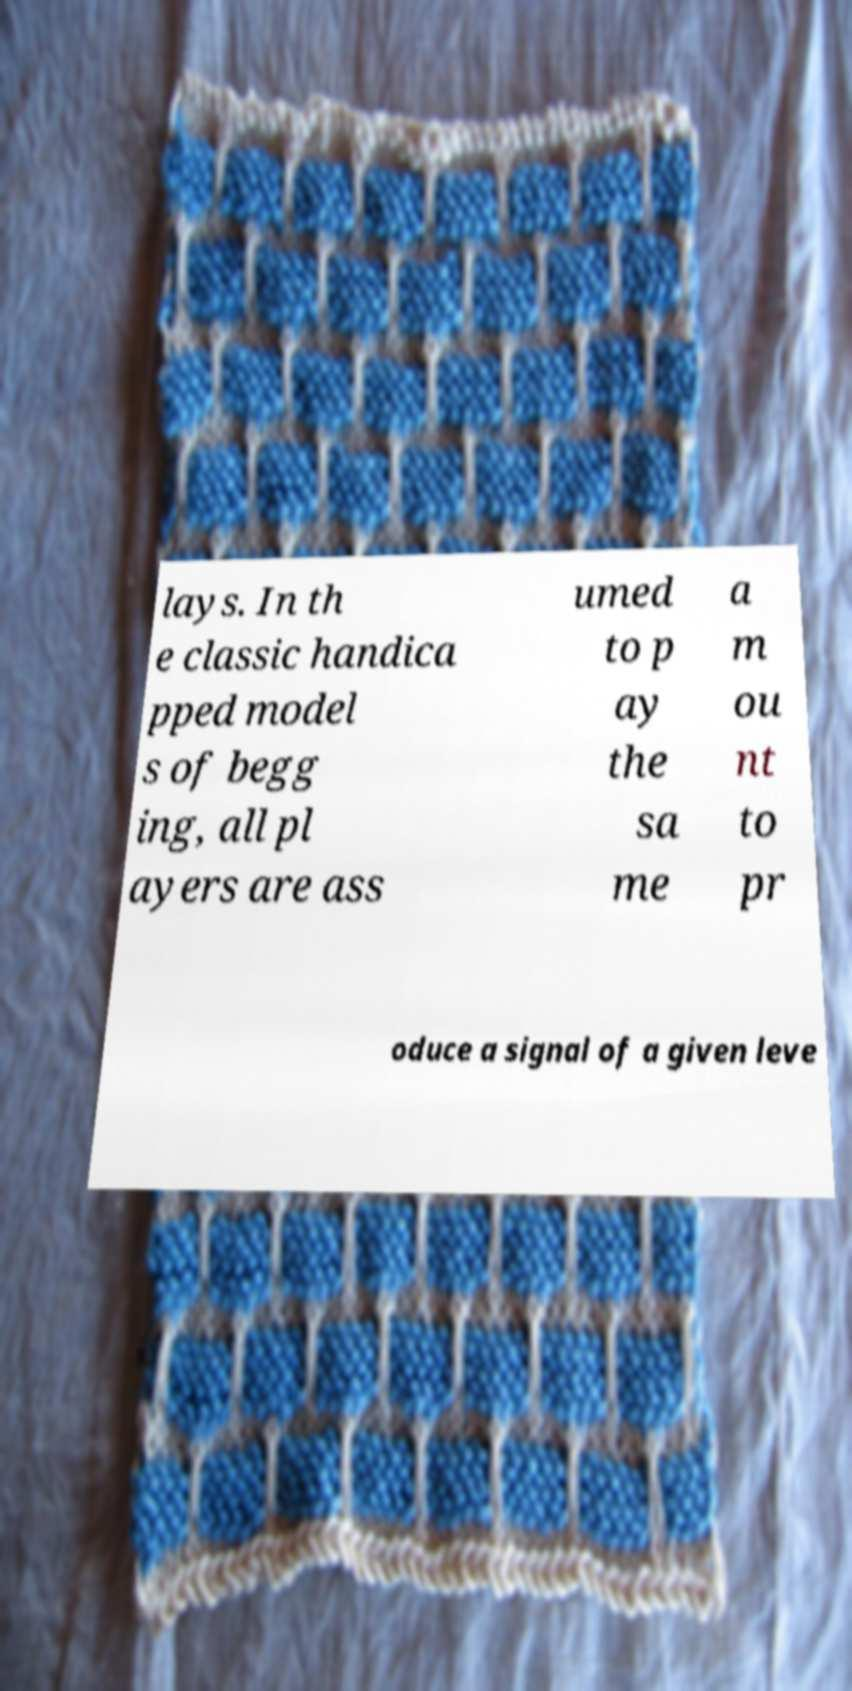What messages or text are displayed in this image? I need them in a readable, typed format. lays. In th e classic handica pped model s of begg ing, all pl ayers are ass umed to p ay the sa me a m ou nt to pr oduce a signal of a given leve 